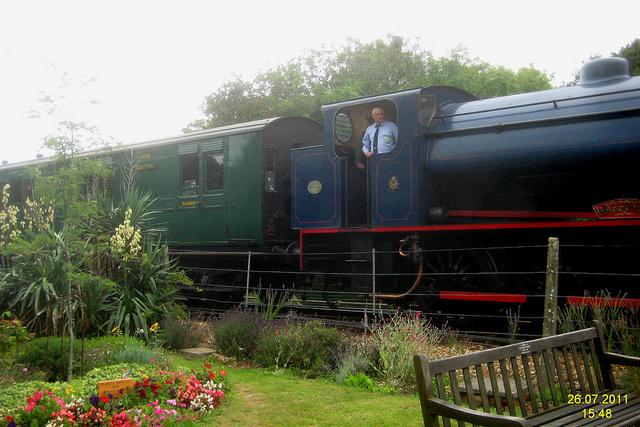What is the man wearing? tie 